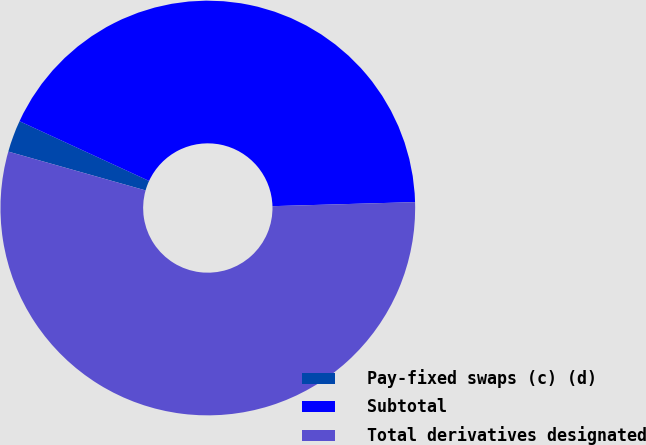<chart> <loc_0><loc_0><loc_500><loc_500><pie_chart><fcel>Pay-fixed swaps (c) (d)<fcel>Subtotal<fcel>Total derivatives designated<nl><fcel>2.49%<fcel>42.67%<fcel>54.84%<nl></chart> 